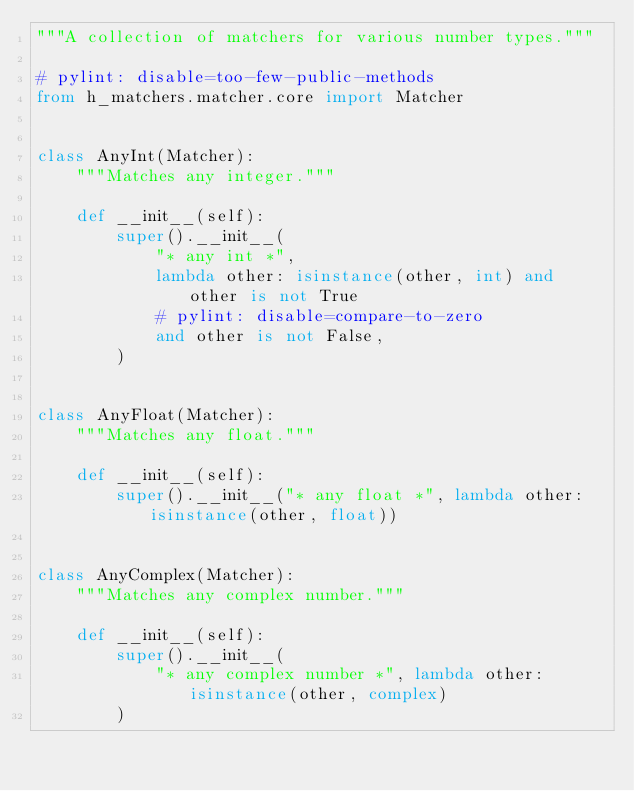<code> <loc_0><loc_0><loc_500><loc_500><_Python_>"""A collection of matchers for various number types."""

# pylint: disable=too-few-public-methods
from h_matchers.matcher.core import Matcher


class AnyInt(Matcher):
    """Matches any integer."""

    def __init__(self):
        super().__init__(
            "* any int *",
            lambda other: isinstance(other, int) and other is not True
            # pylint: disable=compare-to-zero
            and other is not False,
        )


class AnyFloat(Matcher):
    """Matches any float."""

    def __init__(self):
        super().__init__("* any float *", lambda other: isinstance(other, float))


class AnyComplex(Matcher):
    """Matches any complex number."""

    def __init__(self):
        super().__init__(
            "* any complex number *", lambda other: isinstance(other, complex)
        )
</code> 